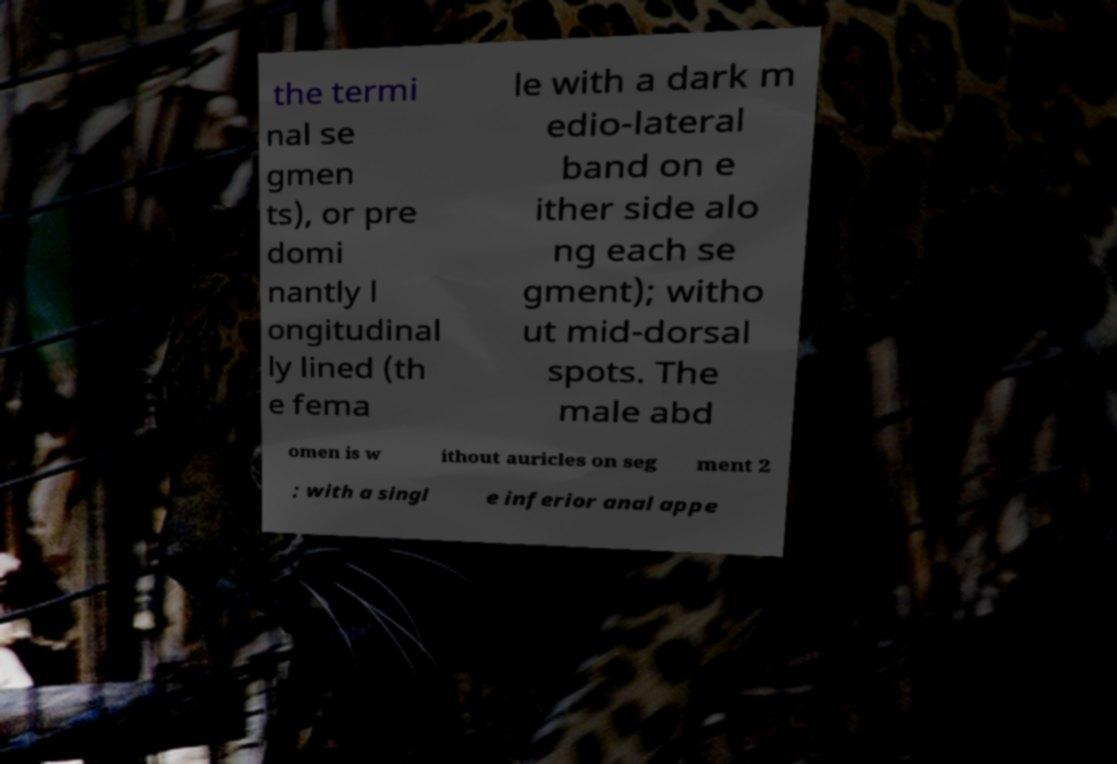Can you accurately transcribe the text from the provided image for me? the termi nal se gmen ts), or pre domi nantly l ongitudinal ly lined (th e fema le with a dark m edio-lateral band on e ither side alo ng each se gment); witho ut mid-dorsal spots. The male abd omen is w ithout auricles on seg ment 2 ; with a singl e inferior anal appe 